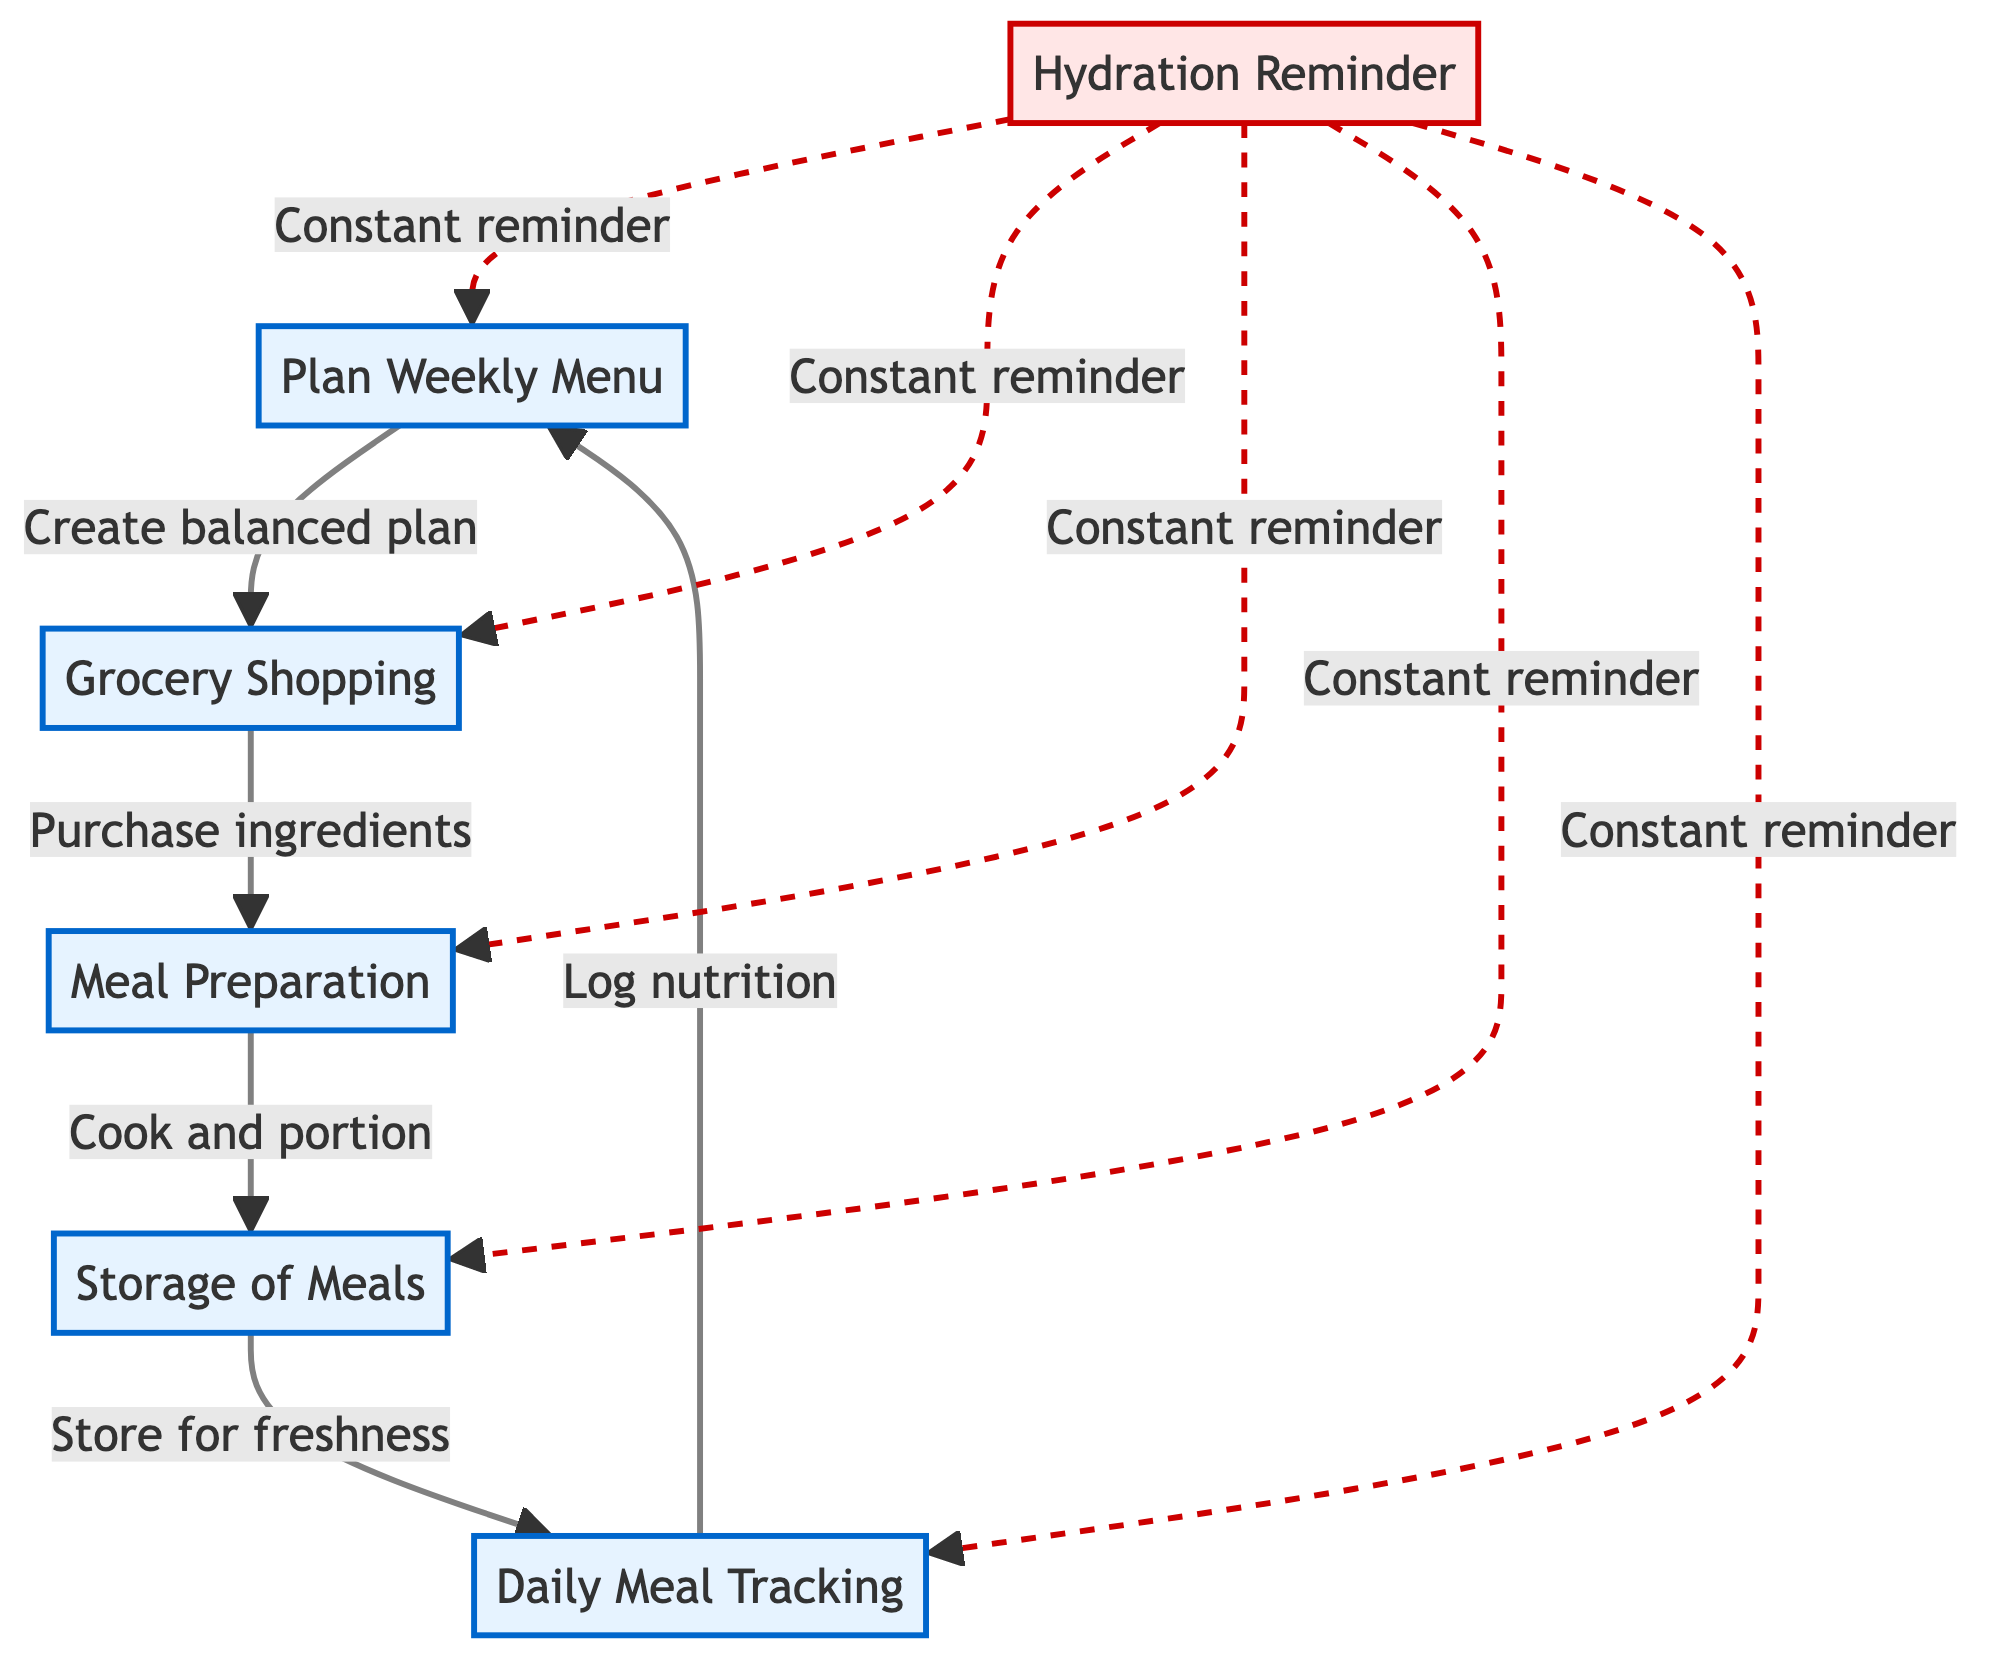What's the first step in the meal prep process? The first step is "Plan Weekly Menu," which is indicated as the starting point in the flowchart.
Answer: Plan Weekly Menu How many nodes are there in the diagram? The diagram consists of six nodes, each representing a step in the meal prep process.
Answer: 6 What follows after "Grocery Shopping"? After "Grocery Shopping," the next step is "Meal Preparation," as shown by the directed arrow from one node to the next.
Answer: Meal Preparation What is the focus of the "Meal Preparation" step? The focus is on "Cook and portion meals for the week," which describes the main activity in that step, indicated directly next to the node.
Answer: Cook and portion meals for the week What type of reminder is associated with hydration in this diagram? The hydration reminder is denoted as a "Constant reminder," which is highlighted in a dashed line connecting it to multiple steps in the process.
Answer: Constant reminder How does "Daily Meal Tracking" relate to "Plan Weekly Menu"? "Daily Meal Tracking" connects back to "Plan Weekly Menu" indicating that logging meals helps ensure that the balanced meal plan is followed throughout the week.
Answer: Log nutrition What step immediately follows "Storage of Meals"? "Storage of Meals" is followed by "Daily Meal Tracking," which involves logging nutrition after meals have been stored.
Answer: Daily Meal Tracking In the diagram, how is the "Hydration Reminder" visually differentiated? The "Hydration Reminder" is visually differentiated by using a red outline and a dashed line, which emphasizes its importance as a reminder in the meal prep process.
Answer: Dashed line How many edges are there that connect the nodes? There are five connections (edges) that direct the flow from one step to another, each indicating the transition in the meal prep process.
Answer: 5 